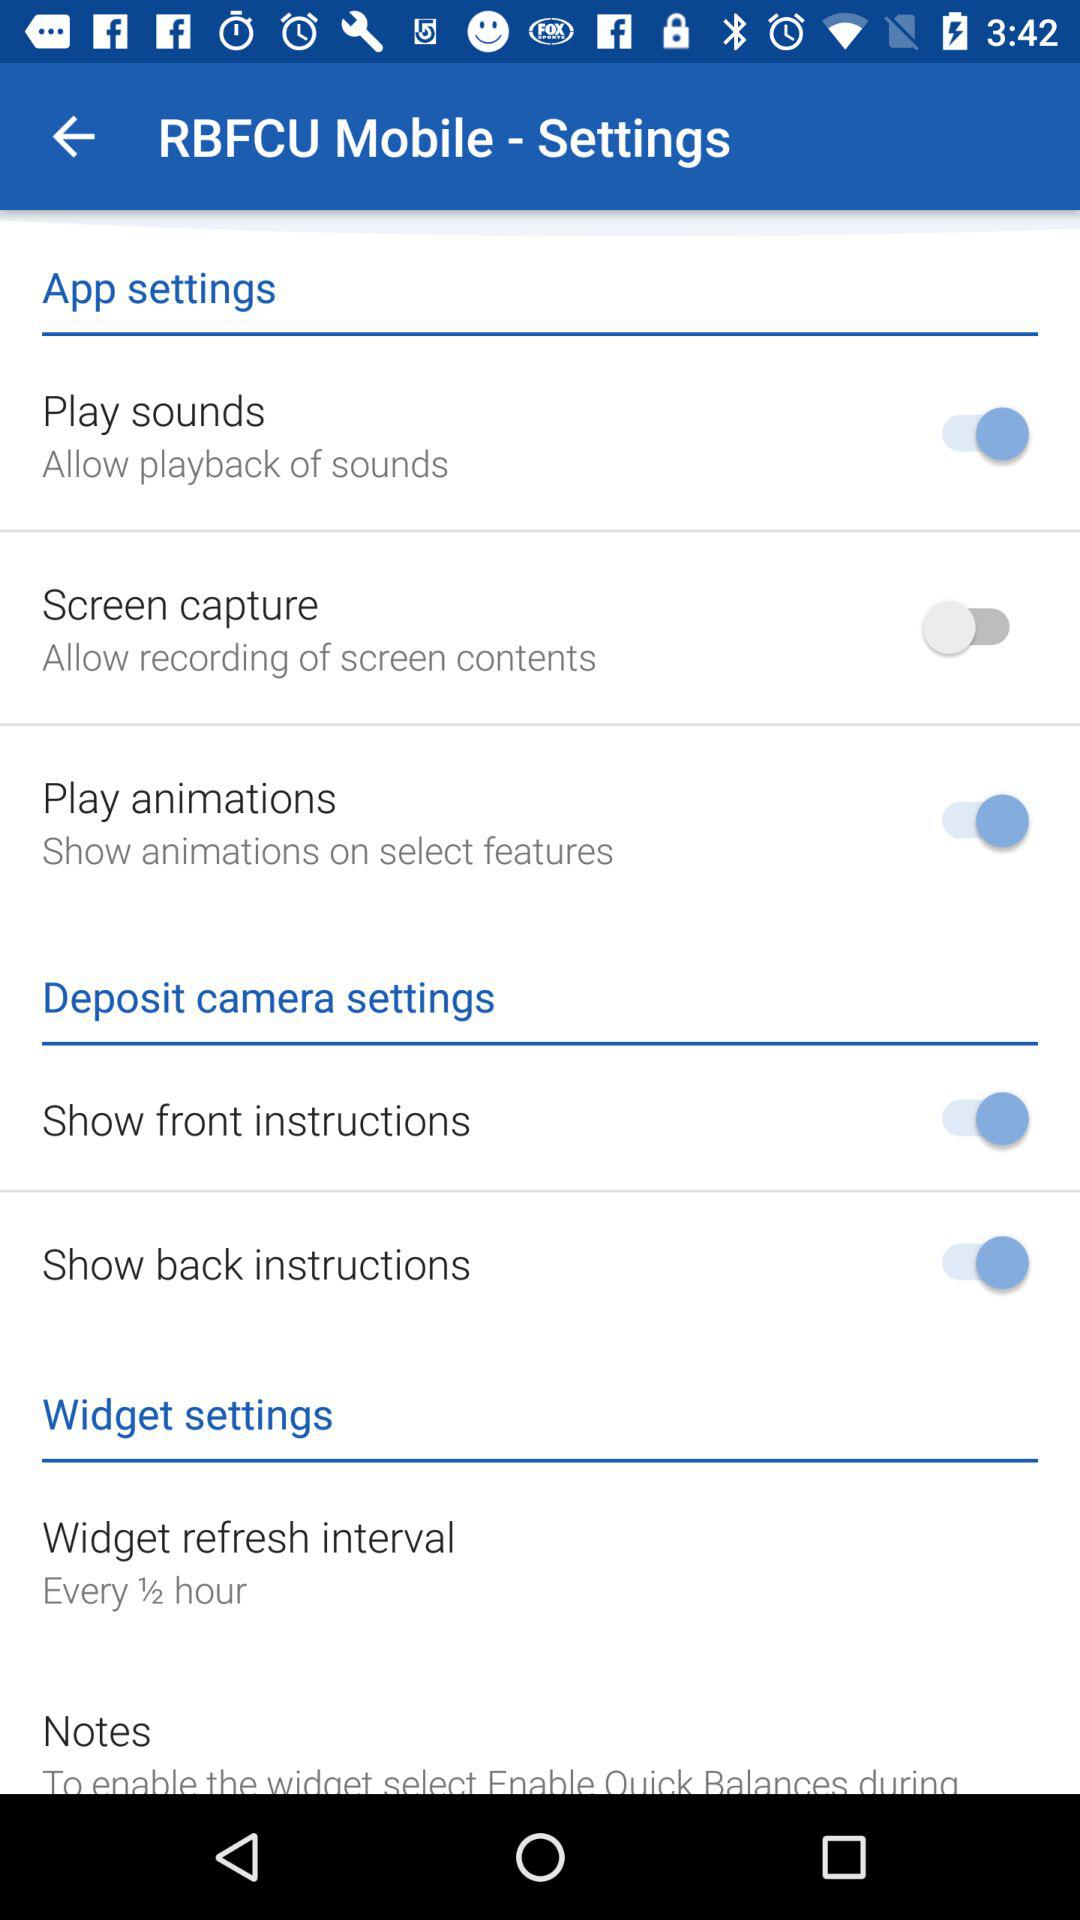What is the widget refresh interval? It refreshes every half hour. 